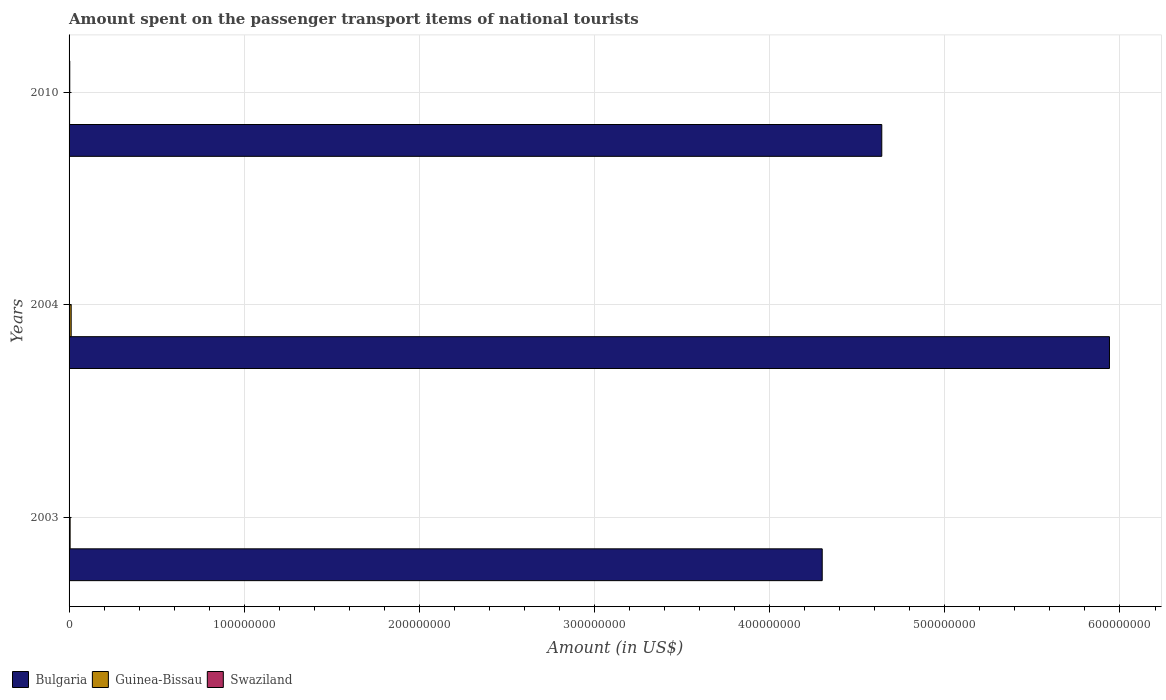How many different coloured bars are there?
Offer a terse response. 3. How many groups of bars are there?
Offer a terse response. 3. Are the number of bars on each tick of the Y-axis equal?
Provide a succinct answer. Yes. How many bars are there on the 3rd tick from the top?
Offer a very short reply. 3. How many bars are there on the 3rd tick from the bottom?
Offer a terse response. 3. What is the label of the 3rd group of bars from the top?
Offer a terse response. 2003. What is the amount spent on the passenger transport items of national tourists in Bulgaria in 2010?
Give a very brief answer. 4.64e+08. Across all years, what is the maximum amount spent on the passenger transport items of national tourists in Bulgaria?
Offer a very short reply. 5.94e+08. Across all years, what is the minimum amount spent on the passenger transport items of national tourists in Swaziland?
Provide a short and direct response. 4.00e+04. In which year was the amount spent on the passenger transport items of national tourists in Guinea-Bissau maximum?
Offer a terse response. 2004. What is the total amount spent on the passenger transport items of national tourists in Guinea-Bissau in the graph?
Provide a succinct answer. 2.10e+06. What is the difference between the amount spent on the passenger transport items of national tourists in Swaziland in 2003 and that in 2004?
Provide a short and direct response. -6.00e+04. What is the difference between the amount spent on the passenger transport items of national tourists in Swaziland in 2004 and the amount spent on the passenger transport items of national tourists in Bulgaria in 2010?
Your response must be concise. -4.64e+08. In the year 2003, what is the difference between the amount spent on the passenger transport items of national tourists in Bulgaria and amount spent on the passenger transport items of national tourists in Swaziland?
Provide a succinct answer. 4.30e+08. In how many years, is the amount spent on the passenger transport items of national tourists in Bulgaria greater than 180000000 US$?
Keep it short and to the point. 3. Is the difference between the amount spent on the passenger transport items of national tourists in Bulgaria in 2003 and 2004 greater than the difference between the amount spent on the passenger transport items of national tourists in Swaziland in 2003 and 2004?
Your response must be concise. No. What is the difference between the highest and the second highest amount spent on the passenger transport items of national tourists in Bulgaria?
Keep it short and to the point. 1.30e+08. Is the sum of the amount spent on the passenger transport items of national tourists in Swaziland in 2004 and 2010 greater than the maximum amount spent on the passenger transport items of national tourists in Bulgaria across all years?
Provide a succinct answer. No. What does the 1st bar from the top in 2010 represents?
Your answer should be very brief. Swaziland. What does the 3rd bar from the bottom in 2003 represents?
Make the answer very short. Swaziland. How many bars are there?
Your response must be concise. 9. How many years are there in the graph?
Make the answer very short. 3. How are the legend labels stacked?
Offer a very short reply. Horizontal. What is the title of the graph?
Give a very brief answer. Amount spent on the passenger transport items of national tourists. What is the label or title of the X-axis?
Offer a very short reply. Amount (in US$). What is the Amount (in US$) in Bulgaria in 2003?
Provide a succinct answer. 4.30e+08. What is the Amount (in US$) of Swaziland in 2003?
Offer a terse response. 4.00e+04. What is the Amount (in US$) of Bulgaria in 2004?
Give a very brief answer. 5.94e+08. What is the Amount (in US$) of Guinea-Bissau in 2004?
Offer a terse response. 1.20e+06. What is the Amount (in US$) in Swaziland in 2004?
Your response must be concise. 1.00e+05. What is the Amount (in US$) in Bulgaria in 2010?
Provide a succinct answer. 4.64e+08. What is the Amount (in US$) of Guinea-Bissau in 2010?
Ensure brevity in your answer.  3.00e+05. Across all years, what is the maximum Amount (in US$) of Bulgaria?
Make the answer very short. 5.94e+08. Across all years, what is the maximum Amount (in US$) in Guinea-Bissau?
Make the answer very short. 1.20e+06. Across all years, what is the minimum Amount (in US$) of Bulgaria?
Offer a terse response. 4.30e+08. Across all years, what is the minimum Amount (in US$) of Swaziland?
Offer a very short reply. 4.00e+04. What is the total Amount (in US$) of Bulgaria in the graph?
Keep it short and to the point. 1.49e+09. What is the total Amount (in US$) in Guinea-Bissau in the graph?
Your answer should be very brief. 2.10e+06. What is the total Amount (in US$) of Swaziland in the graph?
Make the answer very short. 5.40e+05. What is the difference between the Amount (in US$) in Bulgaria in 2003 and that in 2004?
Offer a very short reply. -1.64e+08. What is the difference between the Amount (in US$) of Guinea-Bissau in 2003 and that in 2004?
Provide a short and direct response. -6.00e+05. What is the difference between the Amount (in US$) of Swaziland in 2003 and that in 2004?
Provide a succinct answer. -6.00e+04. What is the difference between the Amount (in US$) in Bulgaria in 2003 and that in 2010?
Make the answer very short. -3.40e+07. What is the difference between the Amount (in US$) in Swaziland in 2003 and that in 2010?
Provide a succinct answer. -3.60e+05. What is the difference between the Amount (in US$) of Bulgaria in 2004 and that in 2010?
Your response must be concise. 1.30e+08. What is the difference between the Amount (in US$) in Guinea-Bissau in 2004 and that in 2010?
Provide a short and direct response. 9.00e+05. What is the difference between the Amount (in US$) in Bulgaria in 2003 and the Amount (in US$) in Guinea-Bissau in 2004?
Make the answer very short. 4.29e+08. What is the difference between the Amount (in US$) of Bulgaria in 2003 and the Amount (in US$) of Swaziland in 2004?
Keep it short and to the point. 4.30e+08. What is the difference between the Amount (in US$) of Bulgaria in 2003 and the Amount (in US$) of Guinea-Bissau in 2010?
Provide a succinct answer. 4.30e+08. What is the difference between the Amount (in US$) of Bulgaria in 2003 and the Amount (in US$) of Swaziland in 2010?
Your response must be concise. 4.30e+08. What is the difference between the Amount (in US$) of Guinea-Bissau in 2003 and the Amount (in US$) of Swaziland in 2010?
Your answer should be compact. 2.00e+05. What is the difference between the Amount (in US$) in Bulgaria in 2004 and the Amount (in US$) in Guinea-Bissau in 2010?
Offer a terse response. 5.94e+08. What is the difference between the Amount (in US$) of Bulgaria in 2004 and the Amount (in US$) of Swaziland in 2010?
Your answer should be compact. 5.94e+08. What is the average Amount (in US$) in Bulgaria per year?
Make the answer very short. 4.96e+08. What is the average Amount (in US$) of Guinea-Bissau per year?
Offer a very short reply. 7.00e+05. What is the average Amount (in US$) of Swaziland per year?
Provide a succinct answer. 1.80e+05. In the year 2003, what is the difference between the Amount (in US$) of Bulgaria and Amount (in US$) of Guinea-Bissau?
Keep it short and to the point. 4.29e+08. In the year 2003, what is the difference between the Amount (in US$) in Bulgaria and Amount (in US$) in Swaziland?
Your answer should be very brief. 4.30e+08. In the year 2003, what is the difference between the Amount (in US$) of Guinea-Bissau and Amount (in US$) of Swaziland?
Your answer should be compact. 5.60e+05. In the year 2004, what is the difference between the Amount (in US$) of Bulgaria and Amount (in US$) of Guinea-Bissau?
Your answer should be compact. 5.93e+08. In the year 2004, what is the difference between the Amount (in US$) of Bulgaria and Amount (in US$) of Swaziland?
Keep it short and to the point. 5.94e+08. In the year 2004, what is the difference between the Amount (in US$) in Guinea-Bissau and Amount (in US$) in Swaziland?
Make the answer very short. 1.10e+06. In the year 2010, what is the difference between the Amount (in US$) of Bulgaria and Amount (in US$) of Guinea-Bissau?
Ensure brevity in your answer.  4.64e+08. In the year 2010, what is the difference between the Amount (in US$) in Bulgaria and Amount (in US$) in Swaziland?
Your response must be concise. 4.64e+08. In the year 2010, what is the difference between the Amount (in US$) of Guinea-Bissau and Amount (in US$) of Swaziland?
Offer a terse response. -1.00e+05. What is the ratio of the Amount (in US$) in Bulgaria in 2003 to that in 2004?
Provide a succinct answer. 0.72. What is the ratio of the Amount (in US$) in Guinea-Bissau in 2003 to that in 2004?
Ensure brevity in your answer.  0.5. What is the ratio of the Amount (in US$) in Bulgaria in 2003 to that in 2010?
Offer a terse response. 0.93. What is the ratio of the Amount (in US$) of Bulgaria in 2004 to that in 2010?
Your answer should be compact. 1.28. What is the ratio of the Amount (in US$) in Guinea-Bissau in 2004 to that in 2010?
Your answer should be compact. 4. What is the ratio of the Amount (in US$) in Swaziland in 2004 to that in 2010?
Make the answer very short. 0.25. What is the difference between the highest and the second highest Amount (in US$) of Bulgaria?
Keep it short and to the point. 1.30e+08. What is the difference between the highest and the lowest Amount (in US$) in Bulgaria?
Make the answer very short. 1.64e+08. 